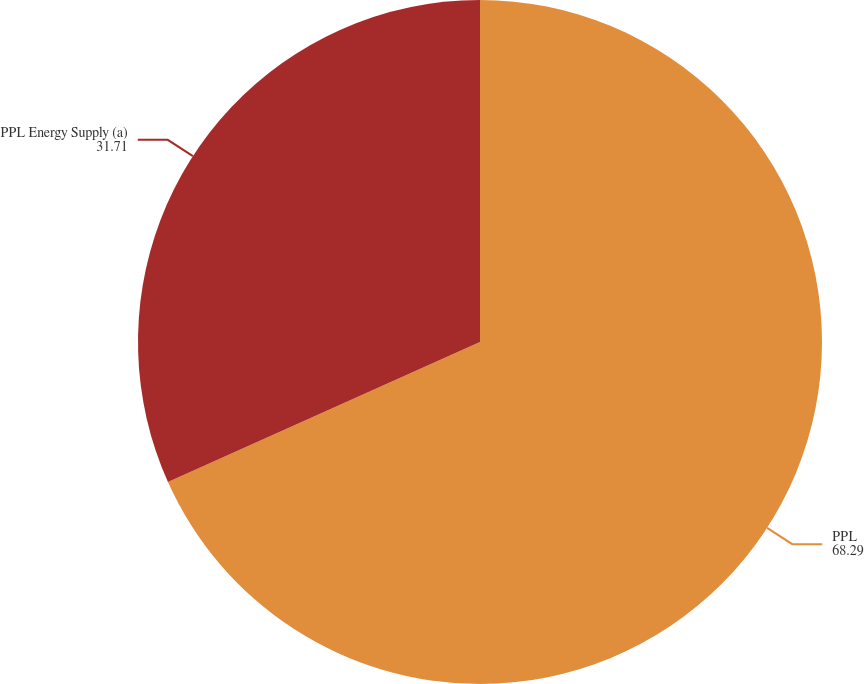Convert chart. <chart><loc_0><loc_0><loc_500><loc_500><pie_chart><fcel>PPL<fcel>PPL Energy Supply (a)<nl><fcel>68.29%<fcel>31.71%<nl></chart> 